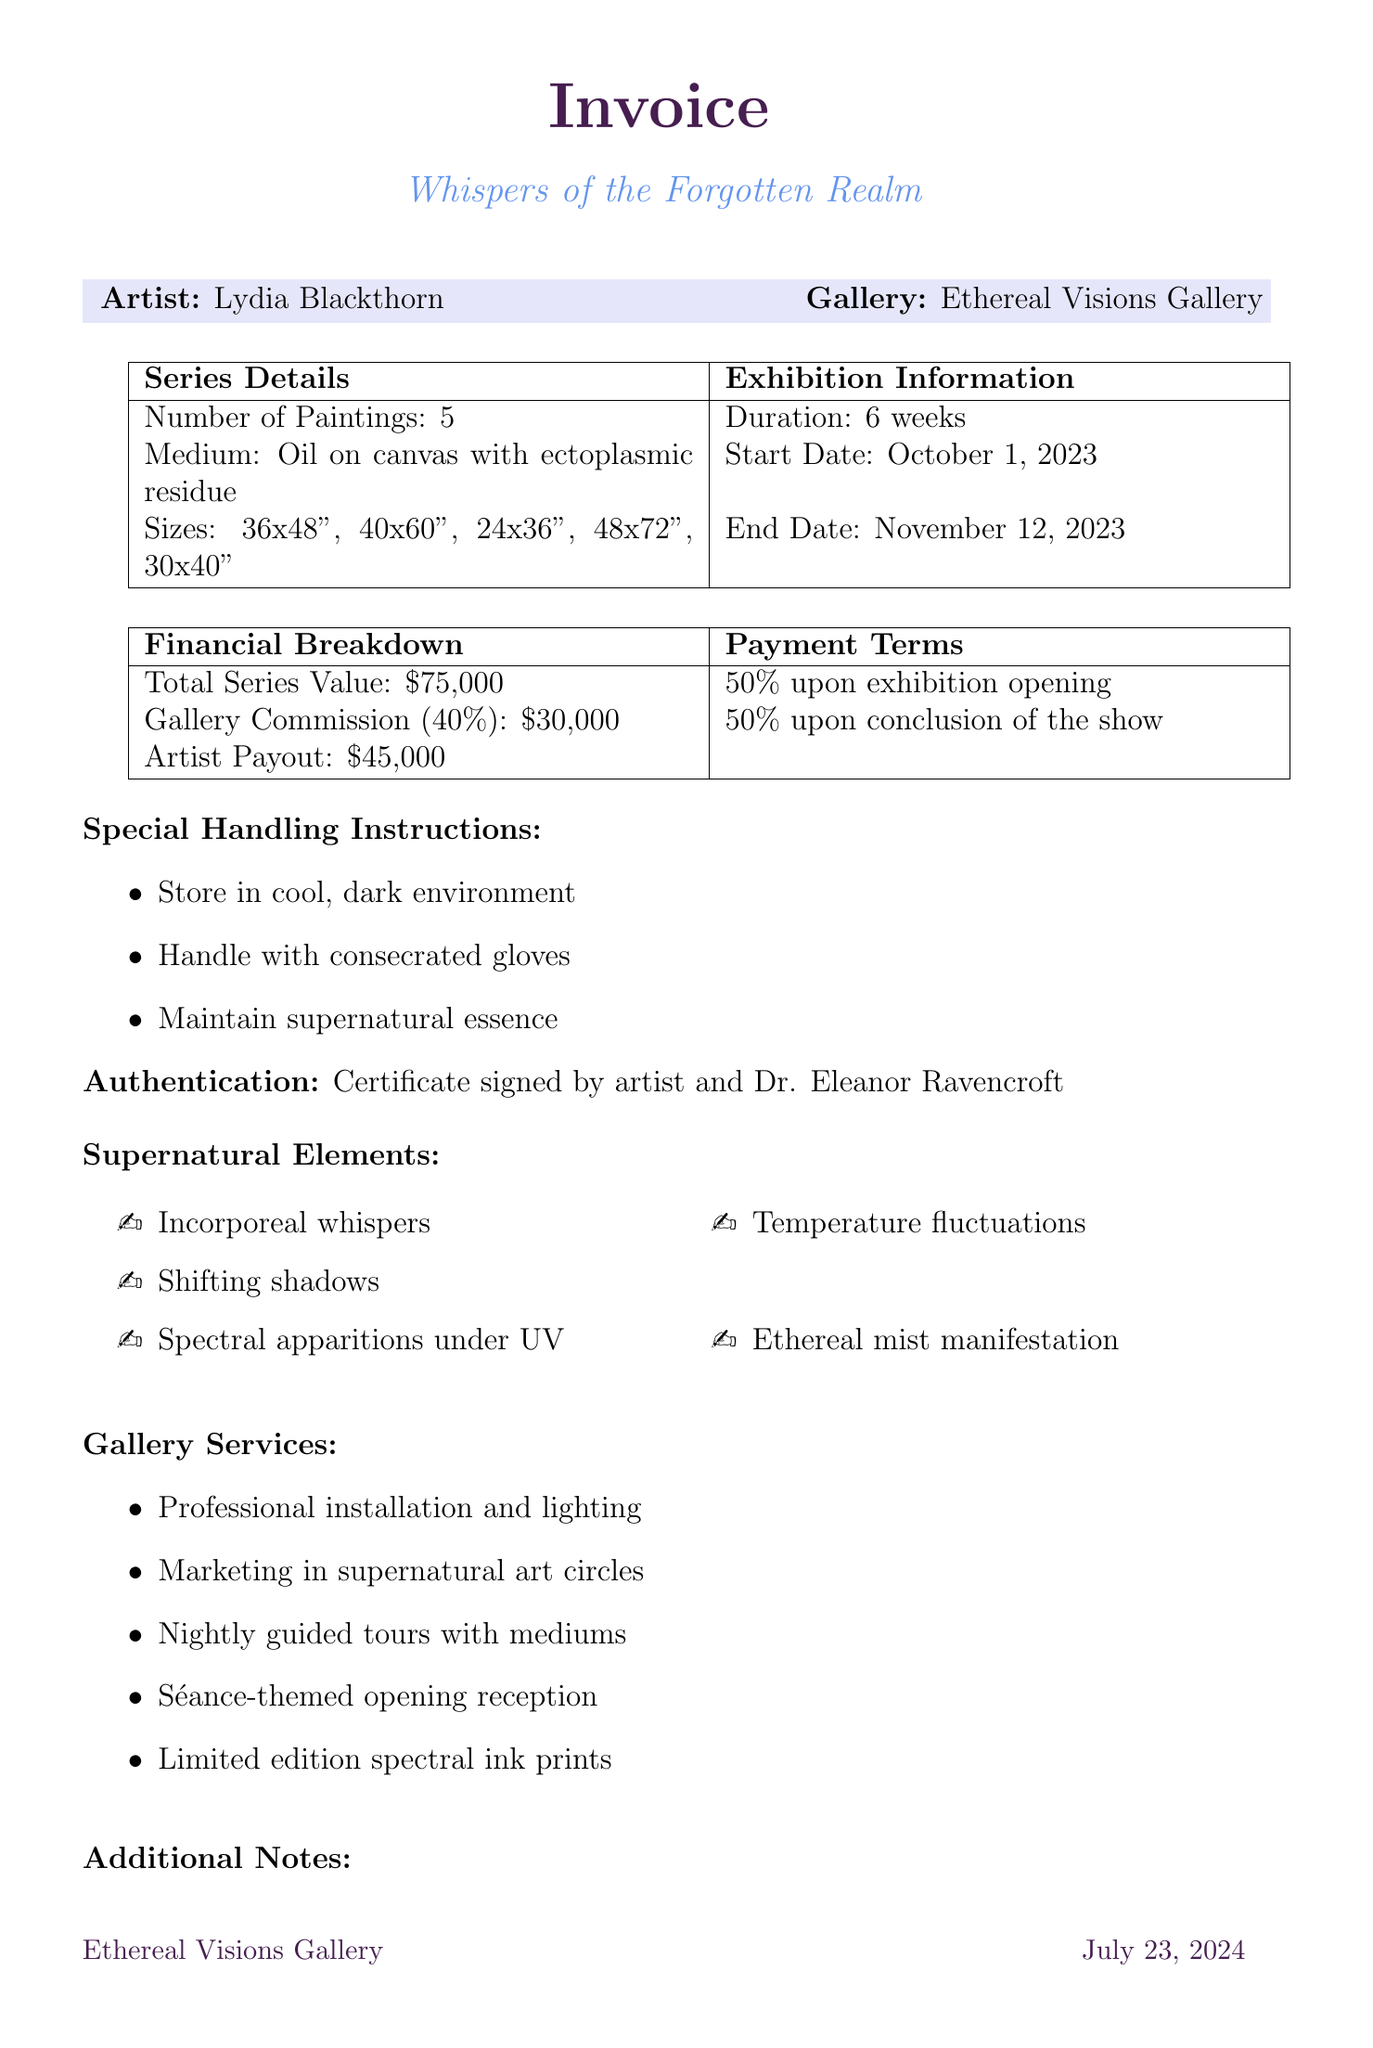what is the artist's name? The document states the artist's name at the top, which is Lydia Blackthorn.
Answer: Lydia Blackthorn what is the total series value? The total series value is clearly mentioned in the financial breakdown section of the document as $75,000.
Answer: $75,000 how many paintings are in the series? The number of paintings is indicated in the series details section of the document, which states there are 5 paintings.
Answer: 5 what percentage is the gallery commission rate? The gallery commission rate is stated in the financial breakdown section as 40%.
Answer: 40% what is the exhibition start date? The exhibition start date is mentioned in the exhibition information section, which is October 1, 2023.
Answer: October 1, 2023 what are the special handling instructions? The special handling instructions are outlined in the document and emphasize storing in a cool, dark environment and handling with consecrated gloves.
Answer: Store in cool, dark environment and handle with consecrated gloves how long is the exhibition duration? The duration of the exhibition is indicated in the document as 6 weeks.
Answer: 6 weeks what is included in the authentication method? The authentication method is described in the document, highlighting a certificate signed by the artist and Dr. Eleanor Ravencroft.
Answer: Certificate signed by artist and Dr. Eleanor Ravencroft what is the insurance coverage provided? The document specifies that there is full value coverage against both mundane and supernatural damages.
Answer: Full value coverage against both mundane and supernatural damages 